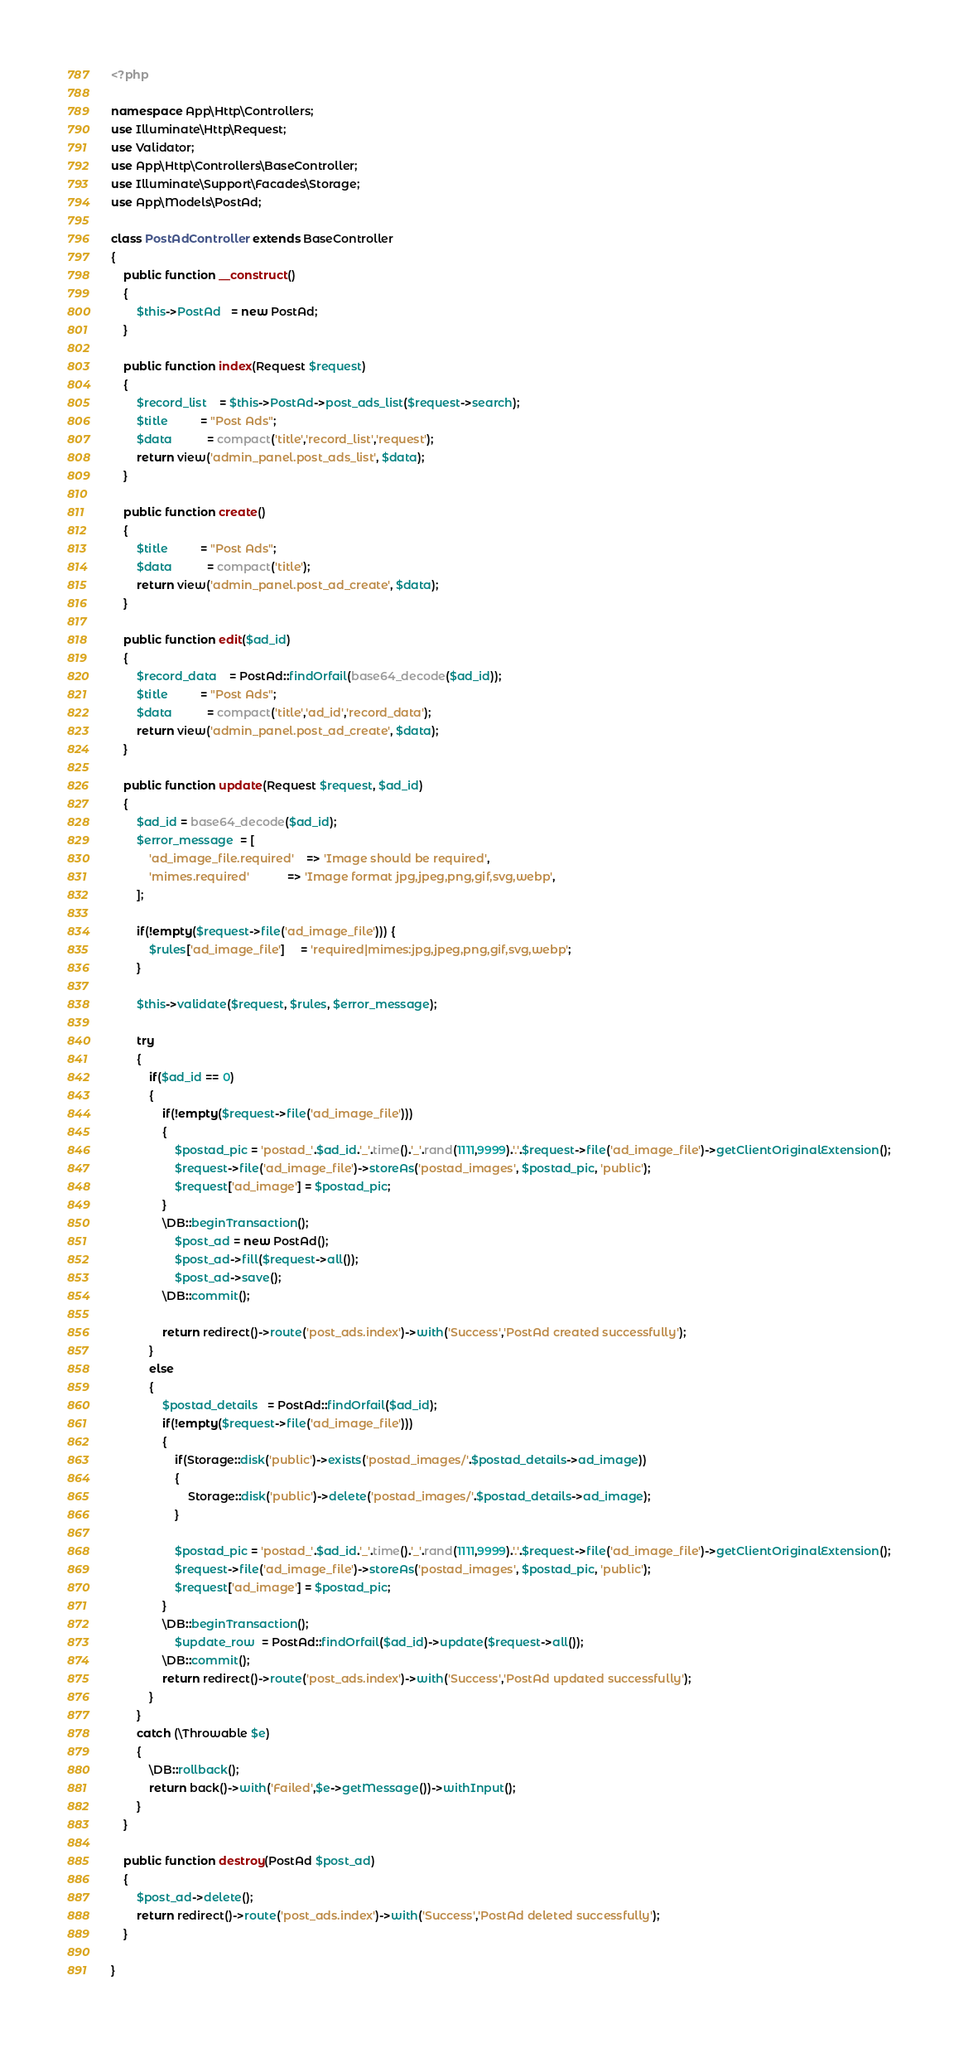Convert code to text. <code><loc_0><loc_0><loc_500><loc_500><_PHP_><?php

namespace App\Http\Controllers;
use Illuminate\Http\Request;
use Validator;
use App\Http\Controllers\BaseController;
use Illuminate\Support\Facades\Storage;
use App\Models\PostAd;

class PostAdController extends BaseController
{
    public function __construct()
    {
        $this->PostAd   = new PostAd;
    }

    public function index(Request $request)
    {
        $record_list    = $this->PostAd->post_ads_list($request->search);
        $title          = "Post Ads";
        $data           = compact('title','record_list','request');
        return view('admin_panel.post_ads_list', $data);
    }

    public function create()
    {
        $title          = "Post Ads";
        $data           = compact('title');
        return view('admin_panel.post_ad_create', $data);
    }

    public function edit($ad_id)
    {
        $record_data    = PostAd::findOrfail(base64_decode($ad_id));
        $title          = "Post Ads";
        $data           = compact('title','ad_id','record_data');
        return view('admin_panel.post_ad_create', $data);
    }

    public function update(Request $request, $ad_id)
    {
        $ad_id = base64_decode($ad_id);
        $error_message  = [
            'ad_image_file.required'    => 'Image should be required',
            'mimes.required'            => 'Image format jpg,jpeg,png,gif,svg,webp',
        ];

        if(!empty($request->file('ad_image_file'))) {
            $rules['ad_image_file']     = 'required|mimes:jpg,jpeg,png,gif,svg,webp';
        }

        $this->validate($request, $rules, $error_message);

        try
        {
            if($ad_id == 0)
            {
                if(!empty($request->file('ad_image_file'))) 
                {
                    $postad_pic = 'postad_'.$ad_id.'_'.time().'_'.rand(1111,9999).'.'.$request->file('ad_image_file')->getClientOriginalExtension();  
                    $request->file('ad_image_file')->storeAs('postad_images', $postad_pic, 'public');
                    $request['ad_image'] = $postad_pic;
                }
                \DB::beginTransaction();
                    $post_ad = new PostAd();
                    $post_ad->fill($request->all());
                    $post_ad->save();
                \DB::commit();
                
                return redirect()->route('post_ads.index')->with('Success','PostAd created successfully');
            }
            else
            {
                $postad_details   = PostAd::findOrfail($ad_id);
                if(!empty($request->file('ad_image_file'))) 
                {
                    if(Storage::disk('public')->exists('postad_images/'.$postad_details->ad_image))
                    {
                        Storage::disk('public')->delete('postad_images/'.$postad_details->ad_image); 
                    }

                    $postad_pic = 'postad_'.$ad_id.'_'.time().'_'.rand(1111,9999).'.'.$request->file('ad_image_file')->getClientOriginalExtension();  
                    $request->file('ad_image_file')->storeAs('postad_images', $postad_pic, 'public');
                    $request['ad_image'] = $postad_pic;
                }
                \DB::beginTransaction();
                    $update_row  = PostAd::findOrfail($ad_id)->update($request->all());
                \DB::commit();
                return redirect()->route('post_ads.index')->with('Success','PostAd updated successfully');
            }
        }
        catch (\Throwable $e)
        {
            \DB::rollback();
            return back()->with('Failed',$e->getMessage())->withInput();
        }
    }

    public function destroy(PostAd $post_ad)
    {
        $post_ad->delete();
        return redirect()->route('post_ads.index')->with('Success','PostAd deleted successfully');
    }

}</code> 